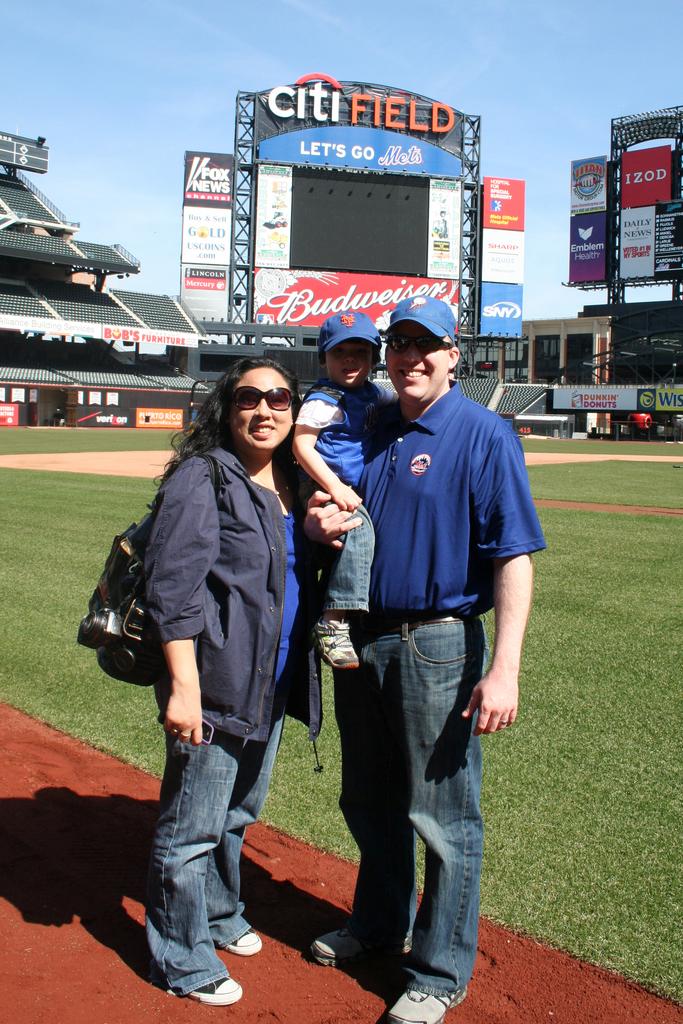What is the stadiums name?
Give a very brief answer. Citi field. What beer is being advertised?
Give a very brief answer. Budweiser. 